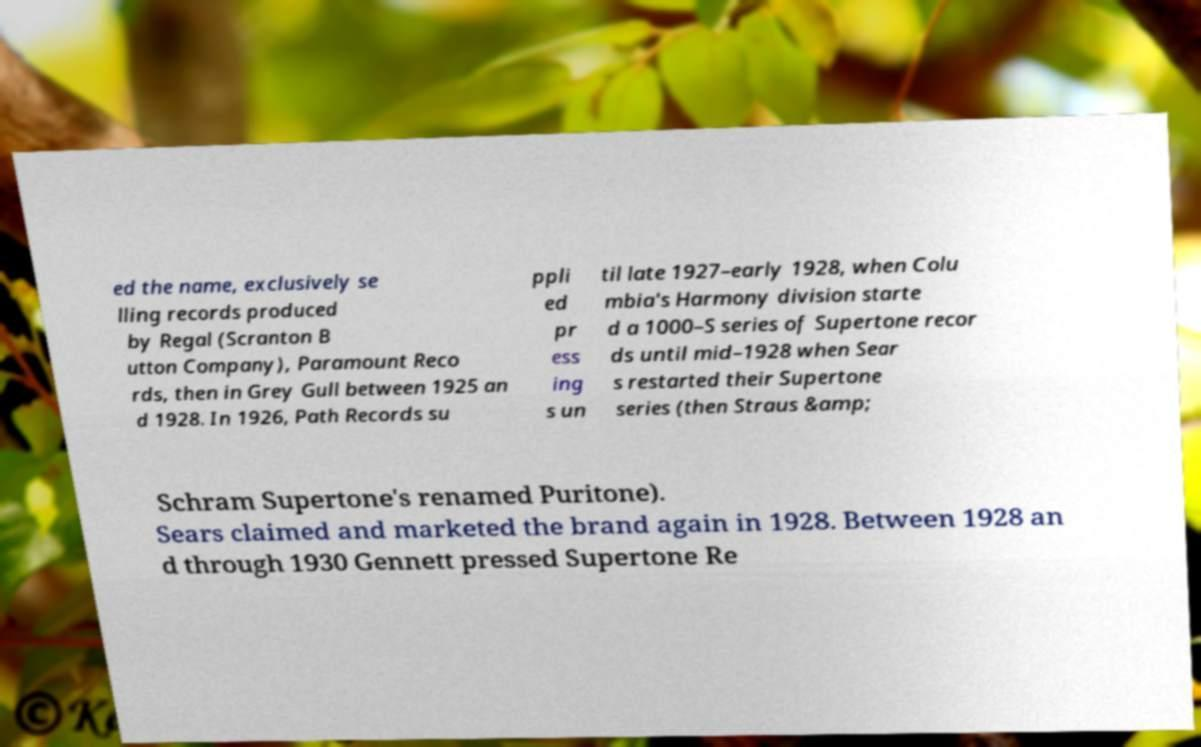Can you accurately transcribe the text from the provided image for me? ed the name, exclusively se lling records produced by Regal (Scranton B utton Company), Paramount Reco rds, then in Grey Gull between 1925 an d 1928. In 1926, Path Records su ppli ed pr ess ing s un til late 1927–early 1928, when Colu mbia's Harmony division starte d a 1000–S series of Supertone recor ds until mid–1928 when Sear s restarted their Supertone series (then Straus &amp; Schram Supertone's renamed Puritone). Sears claimed and marketed the brand again in 1928. Between 1928 an d through 1930 Gennett pressed Supertone Re 